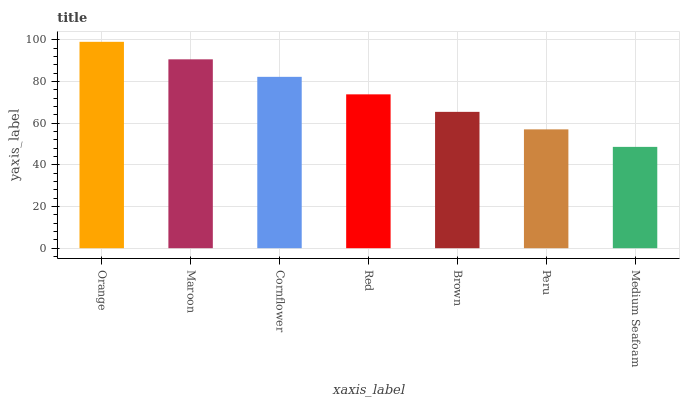Is Medium Seafoam the minimum?
Answer yes or no. Yes. Is Orange the maximum?
Answer yes or no. Yes. Is Maroon the minimum?
Answer yes or no. No. Is Maroon the maximum?
Answer yes or no. No. Is Orange greater than Maroon?
Answer yes or no. Yes. Is Maroon less than Orange?
Answer yes or no. Yes. Is Maroon greater than Orange?
Answer yes or no. No. Is Orange less than Maroon?
Answer yes or no. No. Is Red the high median?
Answer yes or no. Yes. Is Red the low median?
Answer yes or no. Yes. Is Orange the high median?
Answer yes or no. No. Is Cornflower the low median?
Answer yes or no. No. 